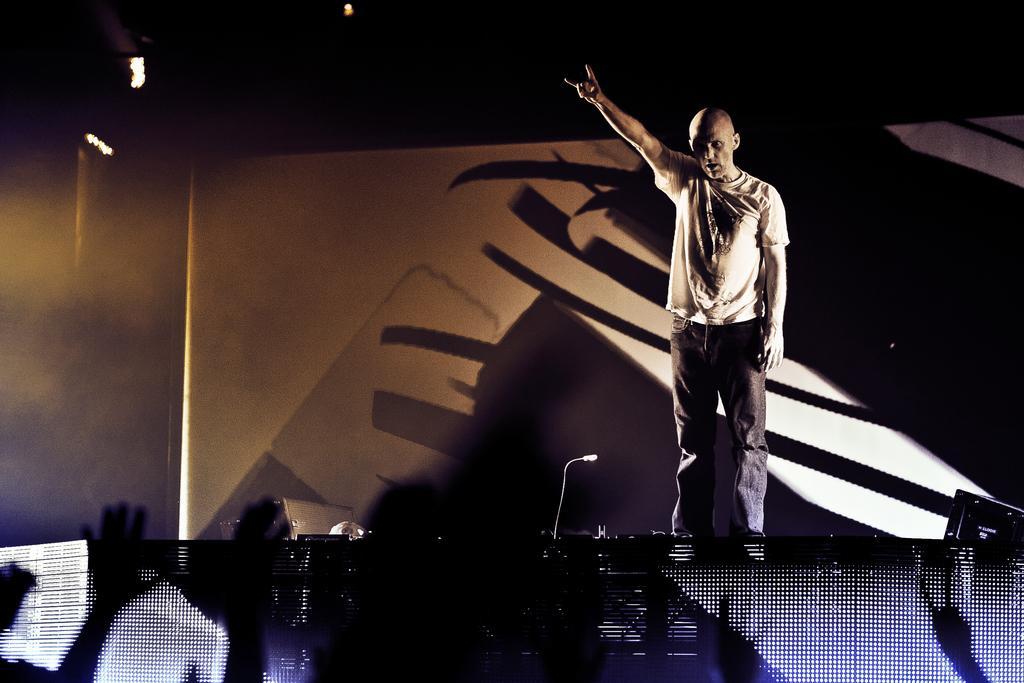Could you give a brief overview of what you see in this image? At the bottom of the image we can see a few human hands. In the center of the image we can see a stage. On the stage, we can see a person is standing. In the background there is a wall, lights and a few other objects. 